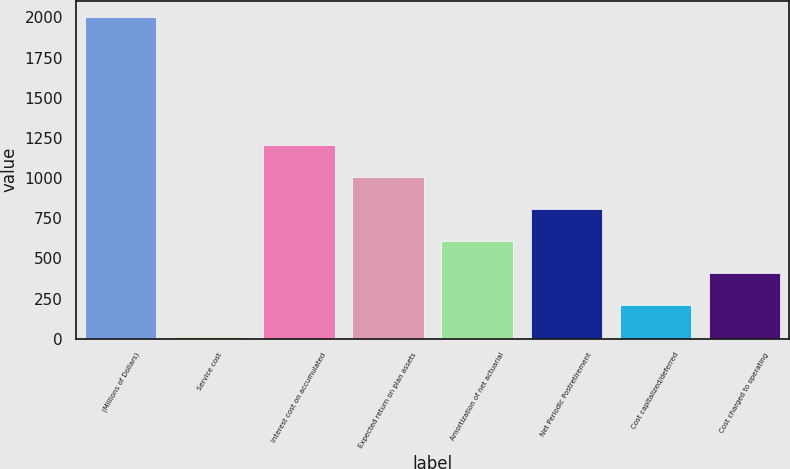<chart> <loc_0><loc_0><loc_500><loc_500><bar_chart><fcel>(Millions of Dollars)<fcel>Service cost<fcel>Interest cost on accumulated<fcel>Expected return on plan assets<fcel>Amortization of net actuarial<fcel>Net Periodic Postretirement<fcel>Cost capitalized/deferred<fcel>Cost charged to operating<nl><fcel>2003<fcel>10<fcel>1205.8<fcel>1006.5<fcel>607.9<fcel>807.2<fcel>209.3<fcel>408.6<nl></chart> 